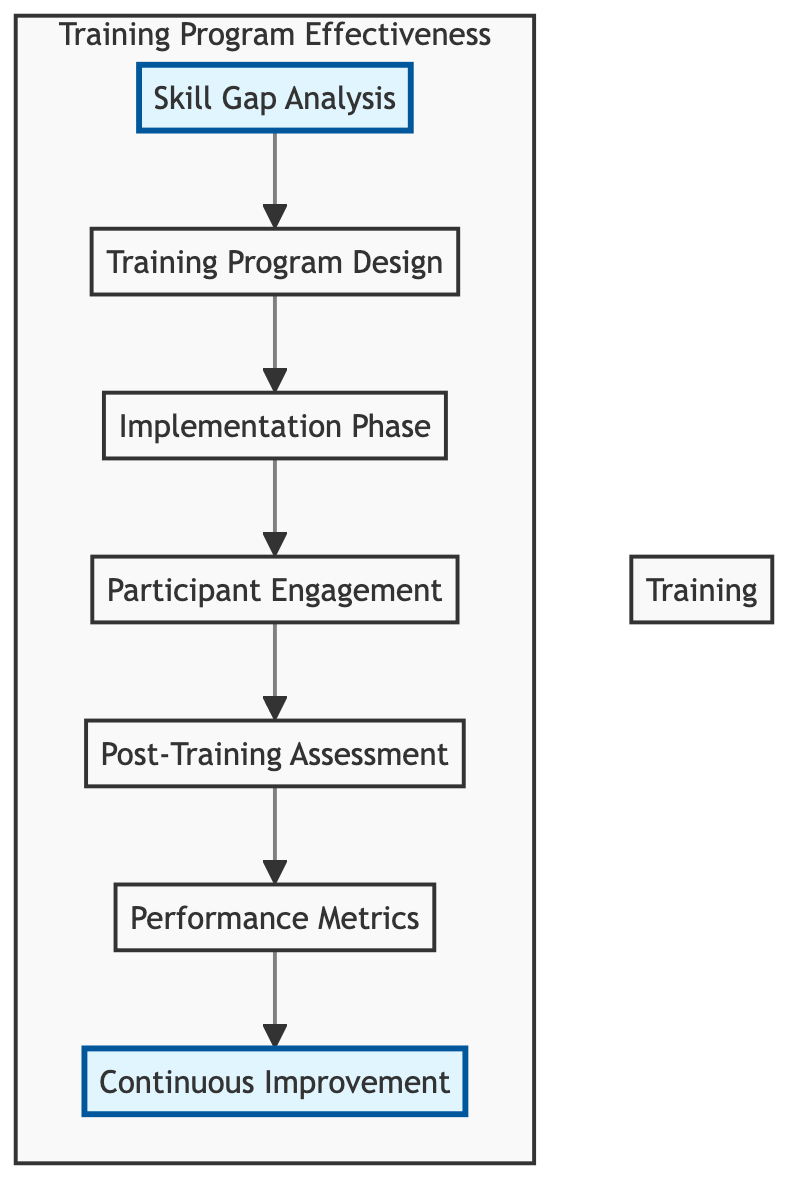What is the first step in the Training Program Effectiveness process? The first step in the diagram is Skill Gap Analysis, which is indicated as the first node at the top of the flow chart.
Answer: Skill Gap Analysis How many total nodes are present in the diagram? Counting all the individual elements listed in the flow chart: Skill Gap Analysis, Training Program Design, Implementation Phase, Participant Engagement, Post-Training Assessment, Performance Metrics, and Continuous Improvement, we find there are a total of seven nodes.
Answer: Seven Which node follows the Training Program Design? Looking at the structure of the flow chart, the node that directly follows Training Program Design is Implementation Phase, as indicated by the arrow from Training Program Design to Implementation Phase.
Answer: Implementation Phase What is the final node in the flow chart? The flow chart progresses to the very last node, which is Continuous Improvement, as it is the last element in the sequential chain of processes depicted.
Answer: Continuous Improvement Describe the flow from Participant Engagement to the next node. Participant Engagement is connected with an arrow to the Post-Training Assessment node. This indicates that the flow of activity moves from measuring participant engagement directly into the evaluation of post-training effectiveness.
Answer: Post-Training Assessment Which assessment follows participant engagement, according to the flow? The flow diagram clearly shows that after Participant Engagement, the next assessment is Post-Training Assessment based on the indicated direction of the arrows between the nodes.
Answer: Post-Training Assessment What is the relationship between Post-Training Assessment and Performance Metrics? The relationship shows a direct progression where Post-Training Assessment leads into Performance Metrics, indicating that the results from the assessment are used to define KPIs for performance measurement.
Answer: Post-Training Assessment leads to Performance Metrics What process occurs after training implementation according to the diagram? After the Implementation Phase of the training program, the flow leads to Participant Engagement, indicating that measuring employee motivation is the immediate subsequent activity after training sessions are held.
Answer: Participant Engagement What does Continuous Improvement relate to in the context of the diagram? Continuous Improvement is related to iterating training programs based on feedback and performance results, illustrating the ongoing nature of the training effectiveness process which focuses on refinement and adaptation.
Answer: Iterating training programs 